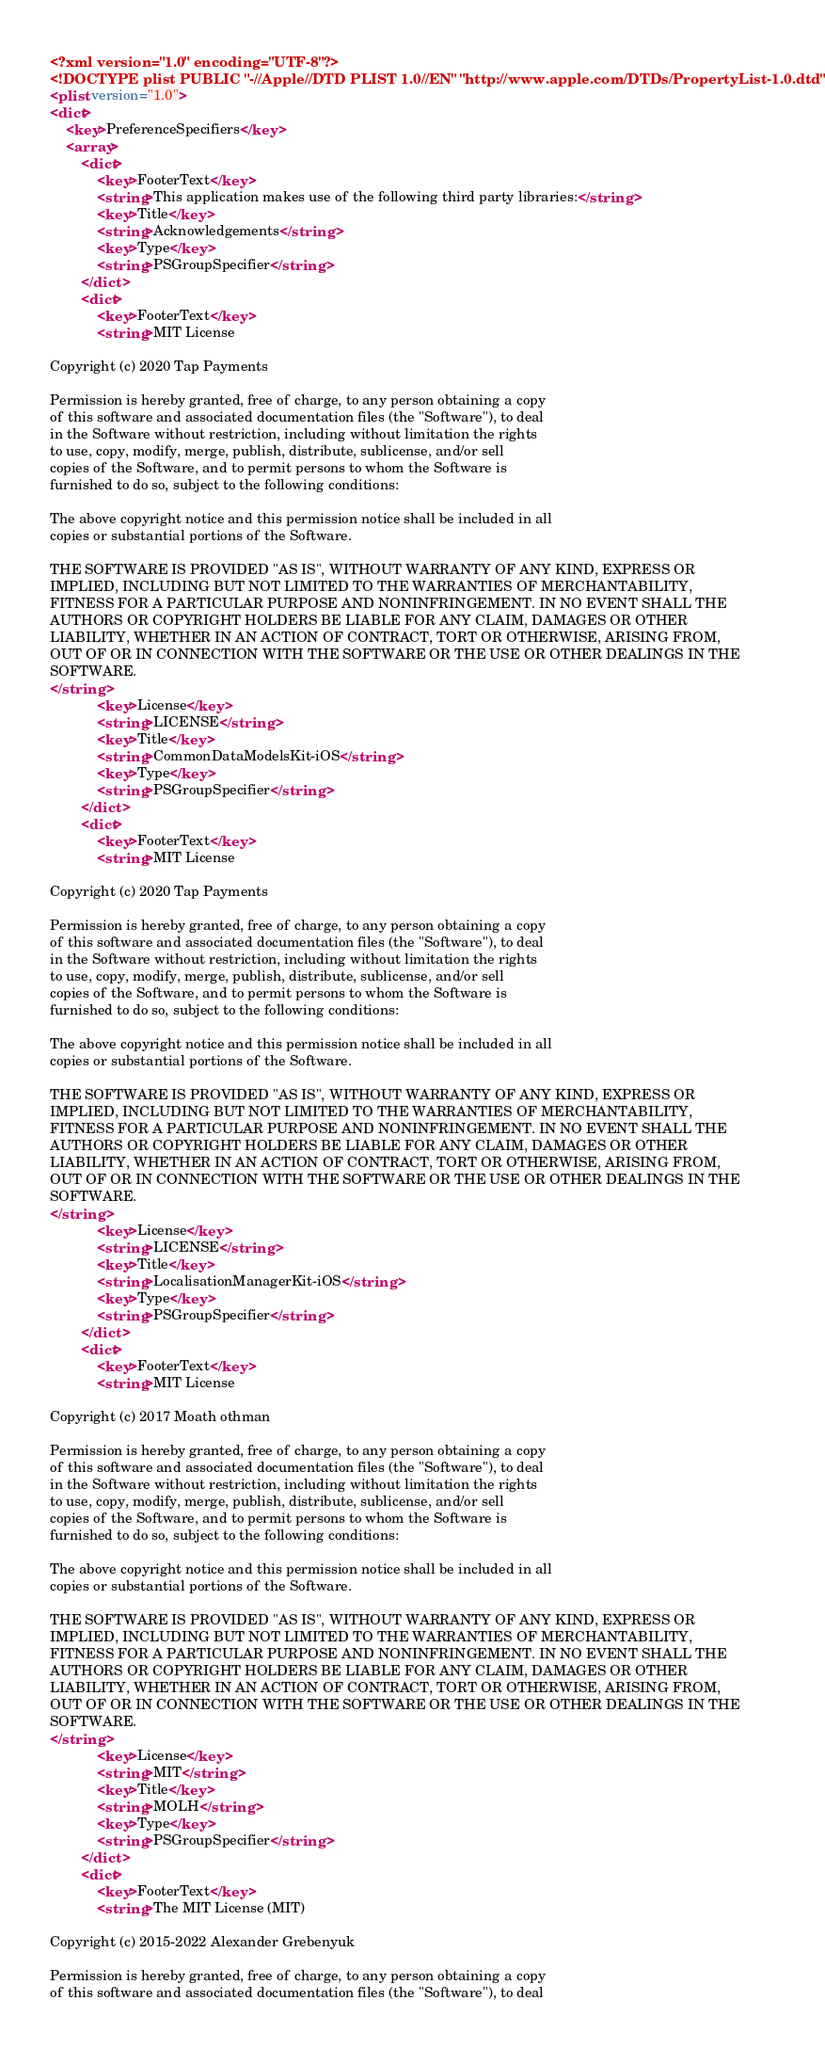<code> <loc_0><loc_0><loc_500><loc_500><_XML_><?xml version="1.0" encoding="UTF-8"?>
<!DOCTYPE plist PUBLIC "-//Apple//DTD PLIST 1.0//EN" "http://www.apple.com/DTDs/PropertyList-1.0.dtd">
<plist version="1.0">
<dict>
	<key>PreferenceSpecifiers</key>
	<array>
		<dict>
			<key>FooterText</key>
			<string>This application makes use of the following third party libraries:</string>
			<key>Title</key>
			<string>Acknowledgements</string>
			<key>Type</key>
			<string>PSGroupSpecifier</string>
		</dict>
		<dict>
			<key>FooterText</key>
			<string>MIT License

Copyright (c) 2020 Tap Payments

Permission is hereby granted, free of charge, to any person obtaining a copy
of this software and associated documentation files (the "Software"), to deal
in the Software without restriction, including without limitation the rights
to use, copy, modify, merge, publish, distribute, sublicense, and/or sell
copies of the Software, and to permit persons to whom the Software is
furnished to do so, subject to the following conditions:

The above copyright notice and this permission notice shall be included in all
copies or substantial portions of the Software.

THE SOFTWARE IS PROVIDED "AS IS", WITHOUT WARRANTY OF ANY KIND, EXPRESS OR
IMPLIED, INCLUDING BUT NOT LIMITED TO THE WARRANTIES OF MERCHANTABILITY,
FITNESS FOR A PARTICULAR PURPOSE AND NONINFRINGEMENT. IN NO EVENT SHALL THE
AUTHORS OR COPYRIGHT HOLDERS BE LIABLE FOR ANY CLAIM, DAMAGES OR OTHER
LIABILITY, WHETHER IN AN ACTION OF CONTRACT, TORT OR OTHERWISE, ARISING FROM,
OUT OF OR IN CONNECTION WITH THE SOFTWARE OR THE USE OR OTHER DEALINGS IN THE
SOFTWARE.
</string>
			<key>License</key>
			<string>LICENSE</string>
			<key>Title</key>
			<string>CommonDataModelsKit-iOS</string>
			<key>Type</key>
			<string>PSGroupSpecifier</string>
		</dict>
		<dict>
			<key>FooterText</key>
			<string>MIT License

Copyright (c) 2020 Tap Payments

Permission is hereby granted, free of charge, to any person obtaining a copy
of this software and associated documentation files (the "Software"), to deal
in the Software without restriction, including without limitation the rights
to use, copy, modify, merge, publish, distribute, sublicense, and/or sell
copies of the Software, and to permit persons to whom the Software is
furnished to do so, subject to the following conditions:

The above copyright notice and this permission notice shall be included in all
copies or substantial portions of the Software.

THE SOFTWARE IS PROVIDED "AS IS", WITHOUT WARRANTY OF ANY KIND, EXPRESS OR
IMPLIED, INCLUDING BUT NOT LIMITED TO THE WARRANTIES OF MERCHANTABILITY,
FITNESS FOR A PARTICULAR PURPOSE AND NONINFRINGEMENT. IN NO EVENT SHALL THE
AUTHORS OR COPYRIGHT HOLDERS BE LIABLE FOR ANY CLAIM, DAMAGES OR OTHER
LIABILITY, WHETHER IN AN ACTION OF CONTRACT, TORT OR OTHERWISE, ARISING FROM,
OUT OF OR IN CONNECTION WITH THE SOFTWARE OR THE USE OR OTHER DEALINGS IN THE
SOFTWARE.
</string>
			<key>License</key>
			<string>LICENSE</string>
			<key>Title</key>
			<string>LocalisationManagerKit-iOS</string>
			<key>Type</key>
			<string>PSGroupSpecifier</string>
		</dict>
		<dict>
			<key>FooterText</key>
			<string>MIT License

Copyright (c) 2017 Moath othman

Permission is hereby granted, free of charge, to any person obtaining a copy
of this software and associated documentation files (the "Software"), to deal
in the Software without restriction, including without limitation the rights
to use, copy, modify, merge, publish, distribute, sublicense, and/or sell
copies of the Software, and to permit persons to whom the Software is
furnished to do so, subject to the following conditions:

The above copyright notice and this permission notice shall be included in all
copies or substantial portions of the Software.

THE SOFTWARE IS PROVIDED "AS IS", WITHOUT WARRANTY OF ANY KIND, EXPRESS OR
IMPLIED, INCLUDING BUT NOT LIMITED TO THE WARRANTIES OF MERCHANTABILITY,
FITNESS FOR A PARTICULAR PURPOSE AND NONINFRINGEMENT. IN NO EVENT SHALL THE
AUTHORS OR COPYRIGHT HOLDERS BE LIABLE FOR ANY CLAIM, DAMAGES OR OTHER
LIABILITY, WHETHER IN AN ACTION OF CONTRACT, TORT OR OTHERWISE, ARISING FROM,
OUT OF OR IN CONNECTION WITH THE SOFTWARE OR THE USE OR OTHER DEALINGS IN THE
SOFTWARE.
</string>
			<key>License</key>
			<string>MIT</string>
			<key>Title</key>
			<string>MOLH</string>
			<key>Type</key>
			<string>PSGroupSpecifier</string>
		</dict>
		<dict>
			<key>FooterText</key>
			<string>The MIT License (MIT)

Copyright (c) 2015-2022 Alexander Grebenyuk

Permission is hereby granted, free of charge, to any person obtaining a copy
of this software and associated documentation files (the "Software"), to deal</code> 